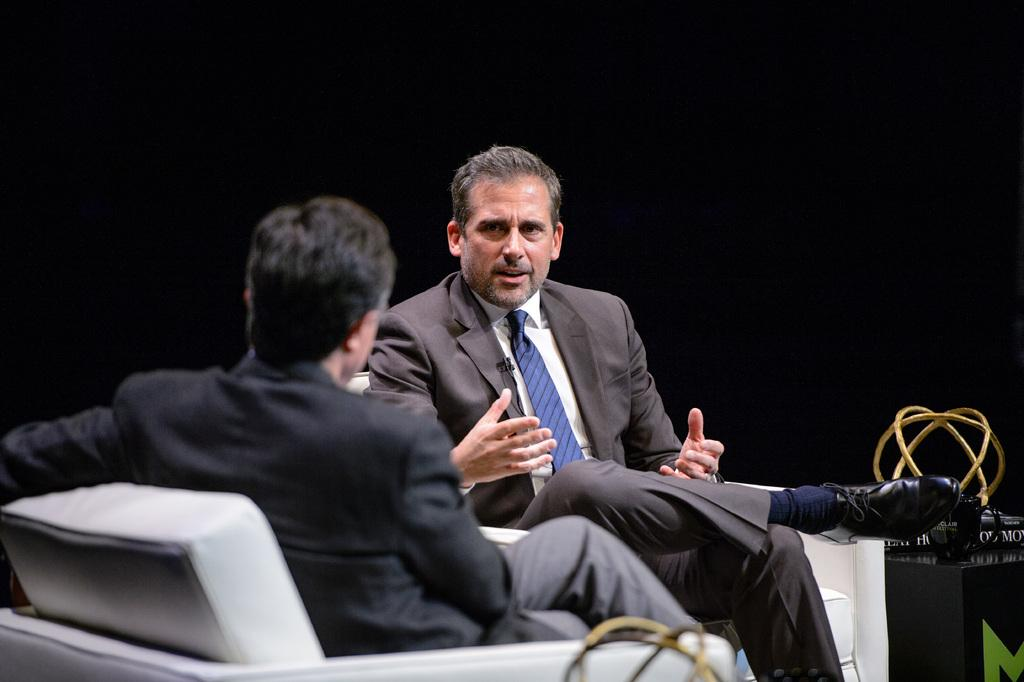How many people are in the image? There are two men in the image. What are the men wearing? The men are wearing blazers. What are the men doing in the image? The men are sitting on chairs. What can be seen on the stand in the image? There is a stand with books in the image, and there is an object on the stand. What is the color of the background in the image? The background of the image is dark. What type of toothpaste is the man holding in the image? There is no toothpaste present in the image. Can you see any roses in the image? There are no roses visible in the image. 